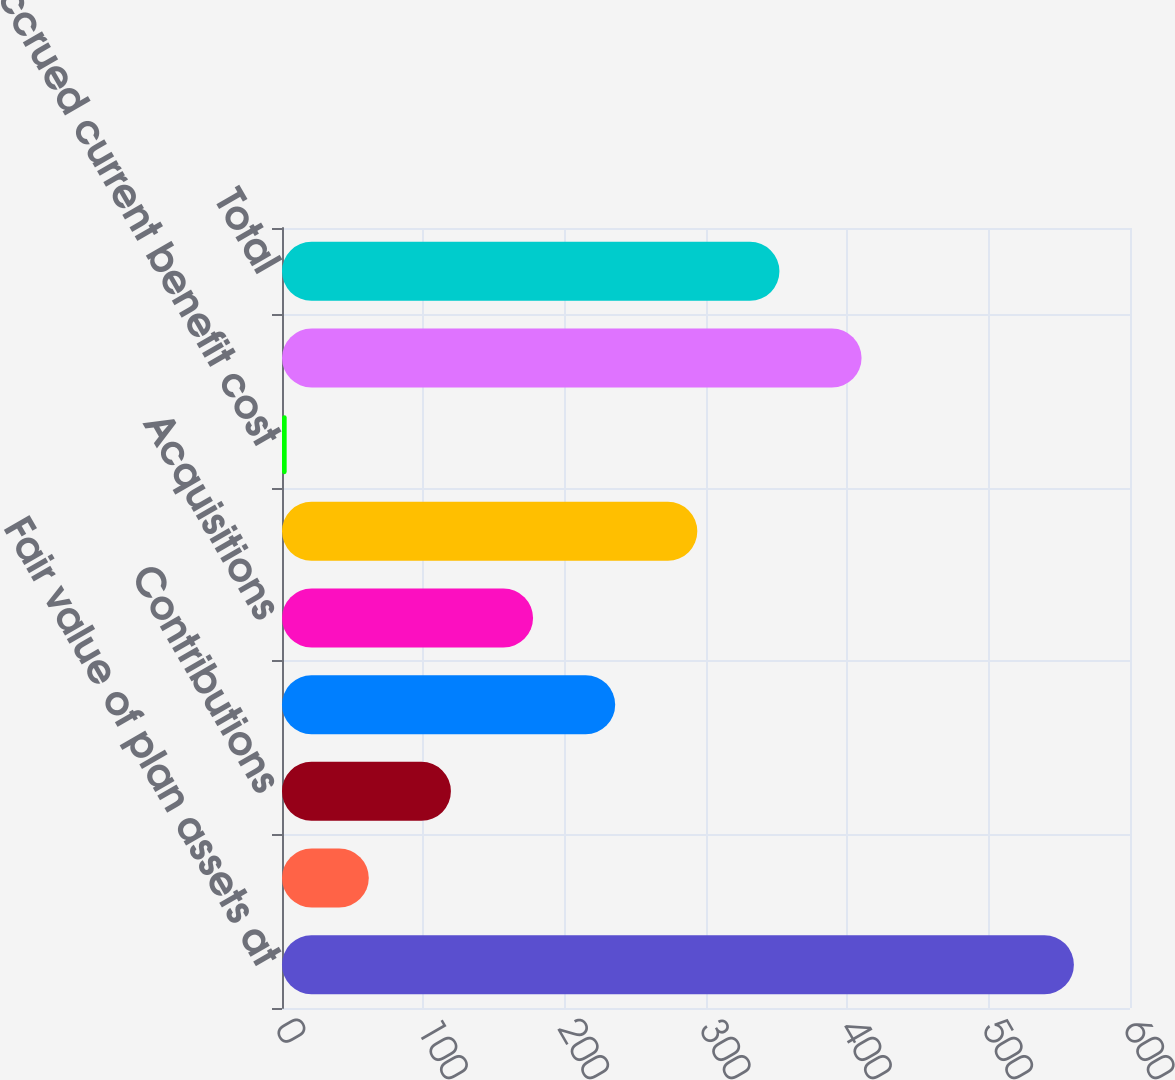Convert chart. <chart><loc_0><loc_0><loc_500><loc_500><bar_chart><fcel>Fair value of plan assets at<fcel>Actual return on plan assets<fcel>Contributions<fcel>Benefits paid<fcel>Acquisitions<fcel>Funded status at end of year<fcel>Accrued current benefit cost<fcel>Accrued noncurrent benefit<fcel>Total<nl><fcel>560.3<fcel>61.41<fcel>119.52<fcel>235.74<fcel>177.63<fcel>293.85<fcel>3.3<fcel>410.07<fcel>351.96<nl></chart> 